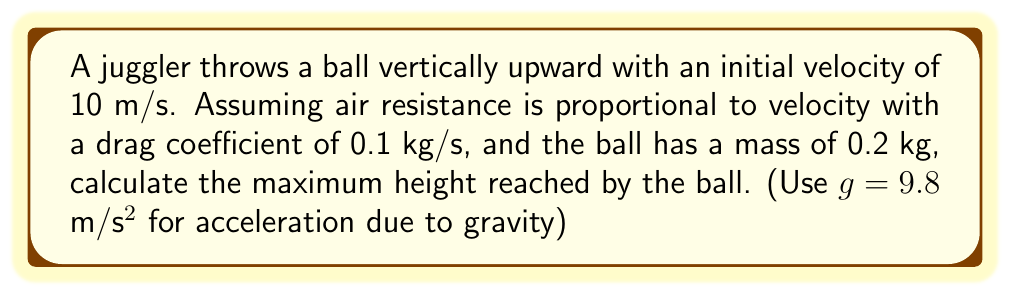Teach me how to tackle this problem. Let's approach this step-by-step:

1) The equation of motion for an object with air resistance proportional to velocity is:

   $$m\frac{dv}{dt} = -mg - bv$$

   where $m$ is mass, $v$ is velocity, $g$ is gravitational acceleration, and $b$ is the drag coefficient.

2) At the maximum height, velocity is zero. So we need to find the time when $v=0$.

3) The solution to this differential equation is:

   $$v(t) = \frac{mg}{b}(e^{-bt/m} - 1) + v_0e^{-bt/m}$$

   where $v_0$ is the initial velocity.

4) Set $v(t) = 0$ and solve for $t$:

   $$0 = \frac{mg}{b}(e^{-bt/m} - 1) + v_0e^{-bt/m}$$
   $$\frac{mg}{b} = \frac{mg}{b}e^{-bt/m} + v_0e^{-bt/m}$$
   $$\frac{mg}{b} = (\frac{mg}{b} + v_0)e^{-bt/m}$$
   $$\ln(\frac{mg}{b}) = \ln(\frac{mg}{b} + v_0) - \frac{bt}{m}$$
   $$t = \frac{m}{b}\ln(1 + \frac{bv_0}{mg})$$

5) Now, to find the maximum height, we integrate velocity from 0 to this time:

   $$h = \int_0^t v(t)dt = \frac{m}{b}(v_0 + \frac{mg}{b})\left(1 - e^{-bt/m}\right) - \frac{mg}{b}t$$

6) Substituting the values:
   $m = 0.2$ kg, $b = 0.1$ kg/s, $g = 9.8$ m/s², $v_0 = 10$ m/s

   $$t = \frac{0.2}{0.1}\ln(1 + \frac{0.1 \cdot 10}{0.2 \cdot 9.8}) = 1.609 \text{ s}$$

   $$h = \frac{0.2}{0.1}(10 + \frac{0.2 \cdot 9.8}{0.1})(1 - e^{-0.1 \cdot 1.609/0.2}) - \frac{0.2 \cdot 9.8}{0.1} \cdot 1.609$$

7) Calculating this gives us the maximum height.
Answer: 5.10 m 